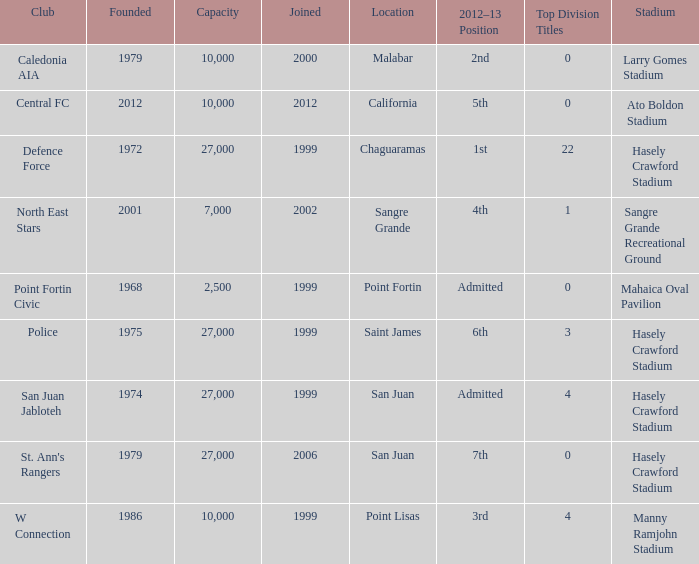Would you mind parsing the complete table? {'header': ['Club', 'Founded', 'Capacity', 'Joined', 'Location', '2012–13 Position', 'Top Division Titles', 'Stadium'], 'rows': [['Caledonia AIA', '1979', '10,000', '2000', 'Malabar', '2nd', '0', 'Larry Gomes Stadium'], ['Central FC', '2012', '10,000', '2012', 'California', '5th', '0', 'Ato Boldon Stadium'], ['Defence Force', '1972', '27,000', '1999', 'Chaguaramas', '1st', '22', 'Hasely Crawford Stadium'], ['North East Stars', '2001', '7,000', '2002', 'Sangre Grande', '4th', '1', 'Sangre Grande Recreational Ground'], ['Point Fortin Civic', '1968', '2,500', '1999', 'Point Fortin', 'Admitted', '0', 'Mahaica Oval Pavilion'], ['Police', '1975', '27,000', '1999', 'Saint James', '6th', '3', 'Hasely Crawford Stadium'], ['San Juan Jabloteh', '1974', '27,000', '1999', 'San Juan', 'Admitted', '4', 'Hasely Crawford Stadium'], ["St. Ann's Rangers", '1979', '27,000', '2006', 'San Juan', '7th', '0', 'Hasely Crawford Stadium'], ['W Connection', '1986', '10,000', '1999', 'Point Lisas', '3rd', '4', 'Manny Ramjohn Stadium']]} Which stadium was used for the North East Stars club? Sangre Grande Recreational Ground. 